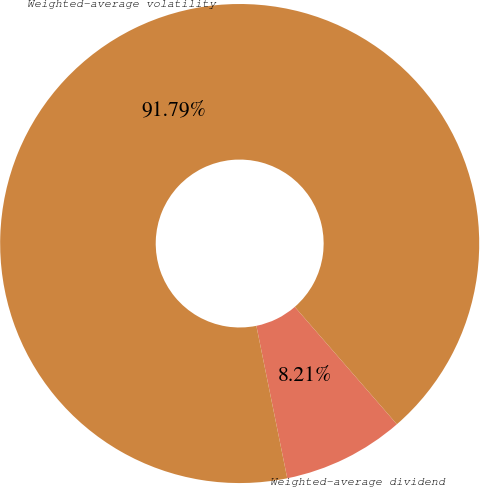Convert chart. <chart><loc_0><loc_0><loc_500><loc_500><pie_chart><fcel>Weighted-average dividend<fcel>Weighted-average volatility<nl><fcel>8.21%<fcel>91.79%<nl></chart> 